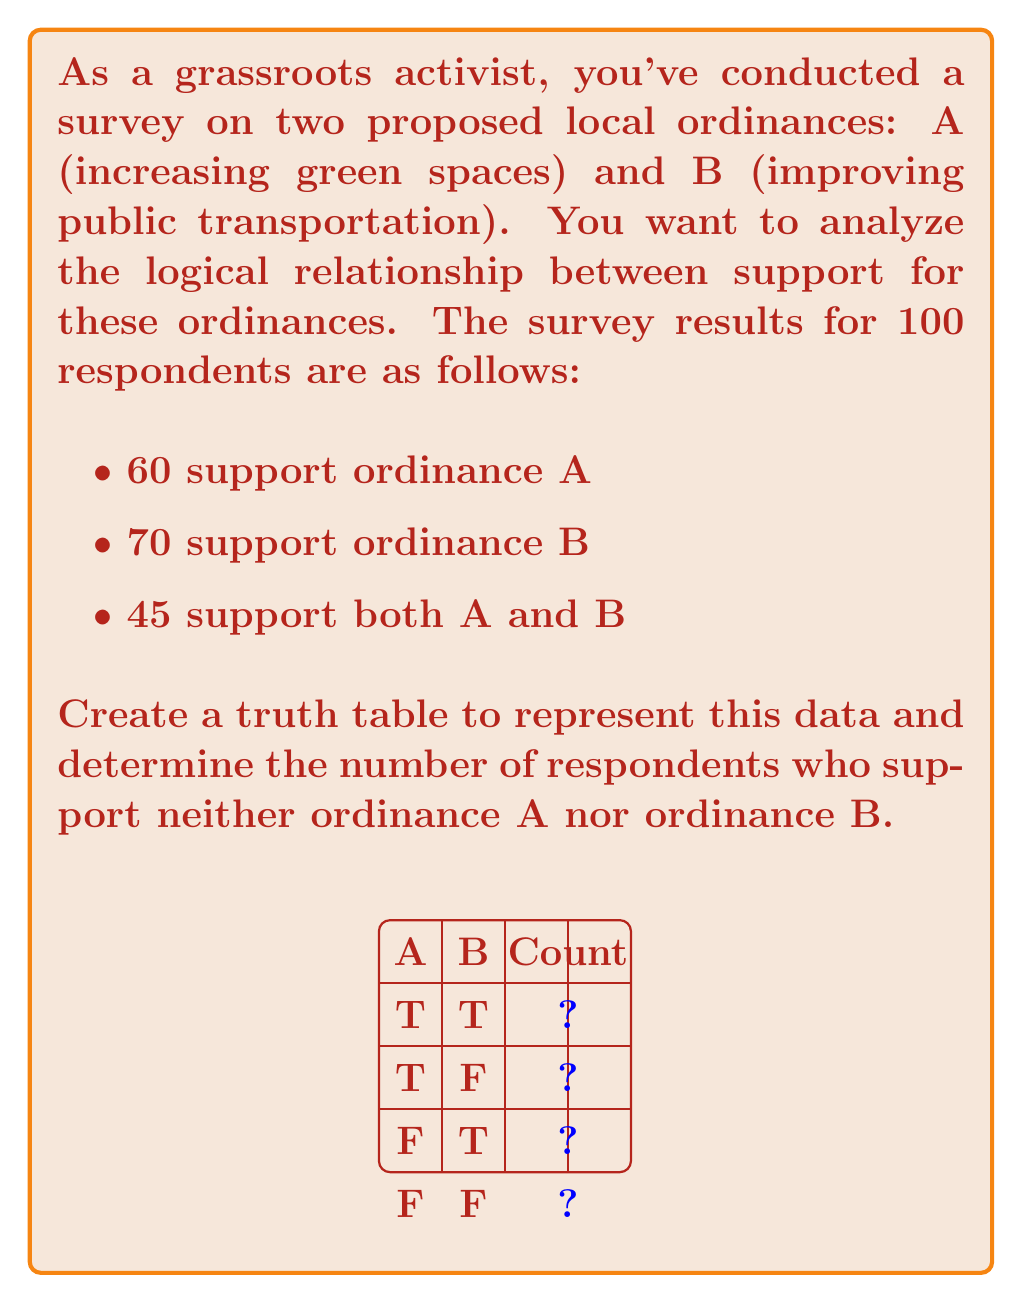Could you help me with this problem? Let's approach this step-by-step:

1) First, we need to understand what each row in the truth table represents:
   - TT: Support both A and B
   - TF: Support A but not B
   - FT: Support B but not A
   - FF: Support neither A nor B

2) We're given the following information:
   - 60 support ordinance A
   - 70 support ordinance B
   - 45 support both A and B

3) Let's fill in the known value:
   - TT = 45 (support both A and B)

4) To find TF (support A but not B):
   - Total supporting A = TT + TF = 60
   - TF = 60 - 45 = 15

5) To find FT (support B but not A):
   - Total supporting B = TT + FT = 70
   - FT = 70 - 45 = 25

6) To find FF (support neither), we use the total number of respondents:
   - Total = TT + TF + FT + FF = 100
   - FF = 100 - (45 + 15 + 25) = 15

7) The completed truth table:

   $$
   \begin{array}{|c|c|c|}
   \hline
   A & B & \text{Count} \\
   \hline
   T & T & 45 \\
   T & F & 15 \\
   F & T & 25 \\
   F & F & 15 \\
   \hline
   \end{array}
   $$

Therefore, 15 respondents support neither ordinance A nor ordinance B.
Answer: 15 